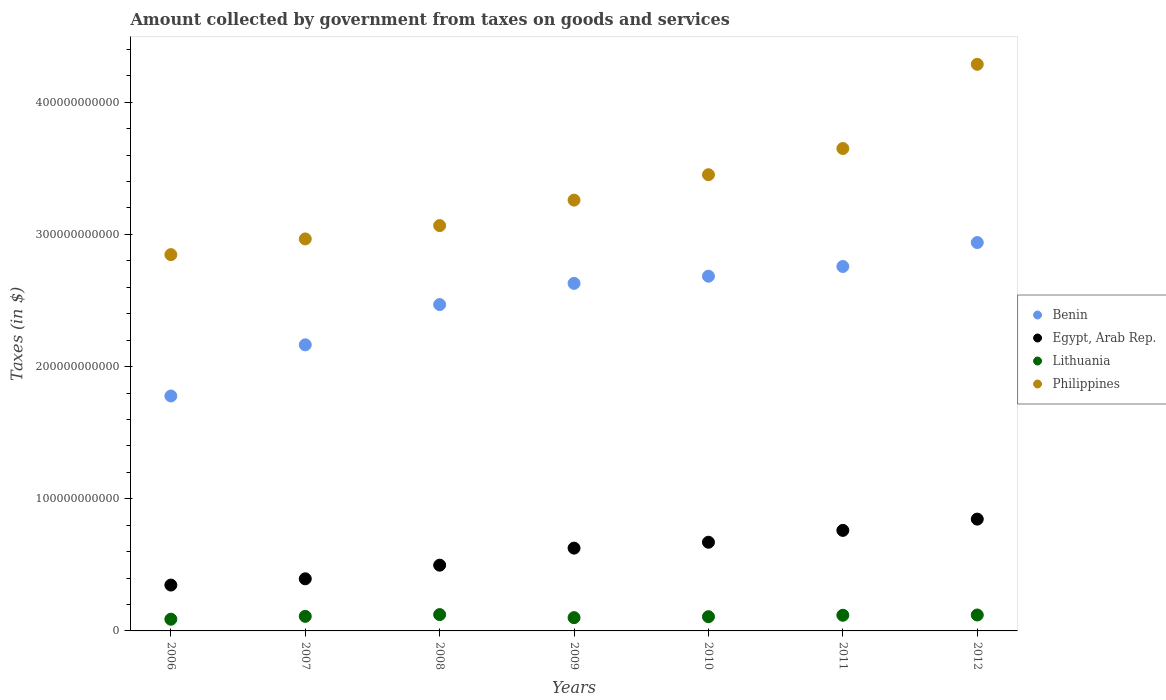Is the number of dotlines equal to the number of legend labels?
Your answer should be very brief. Yes. What is the amount collected by government from taxes on goods and services in Egypt, Arab Rep. in 2007?
Provide a short and direct response. 3.94e+1. Across all years, what is the maximum amount collected by government from taxes on goods and services in Lithuania?
Keep it short and to the point. 1.24e+1. Across all years, what is the minimum amount collected by government from taxes on goods and services in Benin?
Your answer should be compact. 1.78e+11. In which year was the amount collected by government from taxes on goods and services in Benin maximum?
Provide a succinct answer. 2012. In which year was the amount collected by government from taxes on goods and services in Philippines minimum?
Give a very brief answer. 2006. What is the total amount collected by government from taxes on goods and services in Lithuania in the graph?
Ensure brevity in your answer.  7.70e+1. What is the difference between the amount collected by government from taxes on goods and services in Benin in 2009 and that in 2011?
Provide a succinct answer. -1.28e+1. What is the difference between the amount collected by government from taxes on goods and services in Philippines in 2009 and the amount collected by government from taxes on goods and services in Egypt, Arab Rep. in 2008?
Give a very brief answer. 2.76e+11. What is the average amount collected by government from taxes on goods and services in Benin per year?
Keep it short and to the point. 2.49e+11. In the year 2012, what is the difference between the amount collected by government from taxes on goods and services in Egypt, Arab Rep. and amount collected by government from taxes on goods and services in Philippines?
Your answer should be very brief. -3.44e+11. In how many years, is the amount collected by government from taxes on goods and services in Egypt, Arab Rep. greater than 160000000000 $?
Offer a terse response. 0. What is the ratio of the amount collected by government from taxes on goods and services in Philippines in 2007 to that in 2008?
Your answer should be very brief. 0.97. Is the difference between the amount collected by government from taxes on goods and services in Egypt, Arab Rep. in 2007 and 2011 greater than the difference between the amount collected by government from taxes on goods and services in Philippines in 2007 and 2011?
Make the answer very short. Yes. What is the difference between the highest and the second highest amount collected by government from taxes on goods and services in Egypt, Arab Rep.?
Offer a terse response. 8.53e+09. What is the difference between the highest and the lowest amount collected by government from taxes on goods and services in Lithuania?
Ensure brevity in your answer.  3.50e+09. In how many years, is the amount collected by government from taxes on goods and services in Benin greater than the average amount collected by government from taxes on goods and services in Benin taken over all years?
Offer a very short reply. 4. Is the sum of the amount collected by government from taxes on goods and services in Lithuania in 2007 and 2008 greater than the maximum amount collected by government from taxes on goods and services in Benin across all years?
Ensure brevity in your answer.  No. Is it the case that in every year, the sum of the amount collected by government from taxes on goods and services in Egypt, Arab Rep. and amount collected by government from taxes on goods and services in Lithuania  is greater than the amount collected by government from taxes on goods and services in Benin?
Your answer should be compact. No. Does the amount collected by government from taxes on goods and services in Benin monotonically increase over the years?
Make the answer very short. Yes. Is the amount collected by government from taxes on goods and services in Lithuania strictly less than the amount collected by government from taxes on goods and services in Philippines over the years?
Offer a terse response. Yes. How many dotlines are there?
Your response must be concise. 4. How many years are there in the graph?
Make the answer very short. 7. What is the difference between two consecutive major ticks on the Y-axis?
Your answer should be very brief. 1.00e+11. Are the values on the major ticks of Y-axis written in scientific E-notation?
Your answer should be very brief. No. Does the graph contain any zero values?
Provide a succinct answer. No. How many legend labels are there?
Give a very brief answer. 4. How are the legend labels stacked?
Your answer should be compact. Vertical. What is the title of the graph?
Offer a very short reply. Amount collected by government from taxes on goods and services. Does "Azerbaijan" appear as one of the legend labels in the graph?
Offer a terse response. No. What is the label or title of the Y-axis?
Your answer should be compact. Taxes (in $). What is the Taxes (in $) of Benin in 2006?
Your answer should be very brief. 1.78e+11. What is the Taxes (in $) of Egypt, Arab Rep. in 2006?
Offer a terse response. 3.47e+1. What is the Taxes (in $) in Lithuania in 2006?
Your response must be concise. 8.86e+09. What is the Taxes (in $) in Philippines in 2006?
Your answer should be very brief. 2.85e+11. What is the Taxes (in $) in Benin in 2007?
Ensure brevity in your answer.  2.16e+11. What is the Taxes (in $) in Egypt, Arab Rep. in 2007?
Ensure brevity in your answer.  3.94e+1. What is the Taxes (in $) of Lithuania in 2007?
Give a very brief answer. 1.10e+1. What is the Taxes (in $) in Philippines in 2007?
Make the answer very short. 2.97e+11. What is the Taxes (in $) in Benin in 2008?
Give a very brief answer. 2.47e+11. What is the Taxes (in $) of Egypt, Arab Rep. in 2008?
Keep it short and to the point. 4.97e+1. What is the Taxes (in $) of Lithuania in 2008?
Provide a short and direct response. 1.24e+1. What is the Taxes (in $) of Philippines in 2008?
Your answer should be very brief. 3.07e+11. What is the Taxes (in $) in Benin in 2009?
Your answer should be very brief. 2.63e+11. What is the Taxes (in $) of Egypt, Arab Rep. in 2009?
Provide a succinct answer. 6.26e+1. What is the Taxes (in $) of Lithuania in 2009?
Offer a very short reply. 1.00e+1. What is the Taxes (in $) in Philippines in 2009?
Keep it short and to the point. 3.26e+11. What is the Taxes (in $) of Benin in 2010?
Offer a terse response. 2.68e+11. What is the Taxes (in $) of Egypt, Arab Rep. in 2010?
Provide a short and direct response. 6.71e+1. What is the Taxes (in $) in Lithuania in 2010?
Give a very brief answer. 1.08e+1. What is the Taxes (in $) in Philippines in 2010?
Your response must be concise. 3.45e+11. What is the Taxes (in $) of Benin in 2011?
Make the answer very short. 2.76e+11. What is the Taxes (in $) of Egypt, Arab Rep. in 2011?
Ensure brevity in your answer.  7.61e+1. What is the Taxes (in $) of Lithuania in 2011?
Provide a short and direct response. 1.19e+1. What is the Taxes (in $) of Philippines in 2011?
Offer a terse response. 3.65e+11. What is the Taxes (in $) of Benin in 2012?
Offer a very short reply. 2.94e+11. What is the Taxes (in $) in Egypt, Arab Rep. in 2012?
Your answer should be very brief. 8.46e+1. What is the Taxes (in $) of Lithuania in 2012?
Your answer should be very brief. 1.21e+1. What is the Taxes (in $) of Philippines in 2012?
Offer a very short reply. 4.29e+11. Across all years, what is the maximum Taxes (in $) in Benin?
Provide a short and direct response. 2.94e+11. Across all years, what is the maximum Taxes (in $) of Egypt, Arab Rep.?
Provide a short and direct response. 8.46e+1. Across all years, what is the maximum Taxes (in $) of Lithuania?
Keep it short and to the point. 1.24e+1. Across all years, what is the maximum Taxes (in $) in Philippines?
Ensure brevity in your answer.  4.29e+11. Across all years, what is the minimum Taxes (in $) in Benin?
Give a very brief answer. 1.78e+11. Across all years, what is the minimum Taxes (in $) in Egypt, Arab Rep.?
Your answer should be very brief. 3.47e+1. Across all years, what is the minimum Taxes (in $) of Lithuania?
Offer a terse response. 8.86e+09. Across all years, what is the minimum Taxes (in $) in Philippines?
Your answer should be compact. 2.85e+11. What is the total Taxes (in $) in Benin in the graph?
Your answer should be compact. 1.74e+12. What is the total Taxes (in $) of Egypt, Arab Rep. in the graph?
Offer a very short reply. 4.14e+11. What is the total Taxes (in $) in Lithuania in the graph?
Your answer should be compact. 7.70e+1. What is the total Taxes (in $) in Philippines in the graph?
Ensure brevity in your answer.  2.35e+12. What is the difference between the Taxes (in $) in Benin in 2006 and that in 2007?
Provide a succinct answer. -3.87e+1. What is the difference between the Taxes (in $) of Egypt, Arab Rep. in 2006 and that in 2007?
Provide a succinct answer. -4.74e+09. What is the difference between the Taxes (in $) of Lithuania in 2006 and that in 2007?
Offer a terse response. -2.17e+09. What is the difference between the Taxes (in $) in Philippines in 2006 and that in 2007?
Provide a succinct answer. -1.19e+1. What is the difference between the Taxes (in $) in Benin in 2006 and that in 2008?
Offer a very short reply. -6.92e+1. What is the difference between the Taxes (in $) in Egypt, Arab Rep. in 2006 and that in 2008?
Your answer should be compact. -1.50e+1. What is the difference between the Taxes (in $) of Lithuania in 2006 and that in 2008?
Make the answer very short. -3.50e+09. What is the difference between the Taxes (in $) in Philippines in 2006 and that in 2008?
Give a very brief answer. -2.20e+1. What is the difference between the Taxes (in $) of Benin in 2006 and that in 2009?
Offer a terse response. -8.52e+1. What is the difference between the Taxes (in $) of Egypt, Arab Rep. in 2006 and that in 2009?
Your response must be concise. -2.80e+1. What is the difference between the Taxes (in $) in Lithuania in 2006 and that in 2009?
Your answer should be compact. -1.18e+09. What is the difference between the Taxes (in $) in Philippines in 2006 and that in 2009?
Give a very brief answer. -4.12e+1. What is the difference between the Taxes (in $) of Benin in 2006 and that in 2010?
Your answer should be very brief. -9.06e+1. What is the difference between the Taxes (in $) in Egypt, Arab Rep. in 2006 and that in 2010?
Your answer should be compact. -3.24e+1. What is the difference between the Taxes (in $) in Lithuania in 2006 and that in 2010?
Provide a succinct answer. -1.90e+09. What is the difference between the Taxes (in $) of Philippines in 2006 and that in 2010?
Give a very brief answer. -6.05e+1. What is the difference between the Taxes (in $) in Benin in 2006 and that in 2011?
Your response must be concise. -9.80e+1. What is the difference between the Taxes (in $) of Egypt, Arab Rep. in 2006 and that in 2011?
Offer a very short reply. -4.14e+1. What is the difference between the Taxes (in $) in Lithuania in 2006 and that in 2011?
Offer a terse response. -3.00e+09. What is the difference between the Taxes (in $) in Philippines in 2006 and that in 2011?
Ensure brevity in your answer.  -8.03e+1. What is the difference between the Taxes (in $) in Benin in 2006 and that in 2012?
Your response must be concise. -1.16e+11. What is the difference between the Taxes (in $) of Egypt, Arab Rep. in 2006 and that in 2012?
Provide a short and direct response. -4.99e+1. What is the difference between the Taxes (in $) of Lithuania in 2006 and that in 2012?
Keep it short and to the point. -3.20e+09. What is the difference between the Taxes (in $) in Philippines in 2006 and that in 2012?
Your response must be concise. -1.44e+11. What is the difference between the Taxes (in $) of Benin in 2007 and that in 2008?
Make the answer very short. -3.05e+1. What is the difference between the Taxes (in $) of Egypt, Arab Rep. in 2007 and that in 2008?
Your answer should be very brief. -1.03e+1. What is the difference between the Taxes (in $) in Lithuania in 2007 and that in 2008?
Provide a short and direct response. -1.33e+09. What is the difference between the Taxes (in $) of Philippines in 2007 and that in 2008?
Make the answer very short. -1.01e+1. What is the difference between the Taxes (in $) of Benin in 2007 and that in 2009?
Provide a succinct answer. -4.65e+1. What is the difference between the Taxes (in $) of Egypt, Arab Rep. in 2007 and that in 2009?
Your answer should be very brief. -2.32e+1. What is the difference between the Taxes (in $) in Lithuania in 2007 and that in 2009?
Provide a short and direct response. 9.84e+08. What is the difference between the Taxes (in $) of Philippines in 2007 and that in 2009?
Your response must be concise. -2.94e+1. What is the difference between the Taxes (in $) of Benin in 2007 and that in 2010?
Offer a terse response. -5.19e+1. What is the difference between the Taxes (in $) in Egypt, Arab Rep. in 2007 and that in 2010?
Your response must be concise. -2.77e+1. What is the difference between the Taxes (in $) in Lithuania in 2007 and that in 2010?
Your answer should be very brief. 2.73e+08. What is the difference between the Taxes (in $) of Philippines in 2007 and that in 2010?
Give a very brief answer. -4.86e+1. What is the difference between the Taxes (in $) in Benin in 2007 and that in 2011?
Keep it short and to the point. -5.93e+1. What is the difference between the Taxes (in $) of Egypt, Arab Rep. in 2007 and that in 2011?
Your response must be concise. -3.66e+1. What is the difference between the Taxes (in $) in Lithuania in 2007 and that in 2011?
Your answer should be very brief. -8.32e+08. What is the difference between the Taxes (in $) of Philippines in 2007 and that in 2011?
Provide a succinct answer. -6.84e+1. What is the difference between the Taxes (in $) in Benin in 2007 and that in 2012?
Offer a terse response. -7.74e+1. What is the difference between the Taxes (in $) of Egypt, Arab Rep. in 2007 and that in 2012?
Keep it short and to the point. -4.52e+1. What is the difference between the Taxes (in $) of Lithuania in 2007 and that in 2012?
Offer a terse response. -1.03e+09. What is the difference between the Taxes (in $) in Philippines in 2007 and that in 2012?
Keep it short and to the point. -1.32e+11. What is the difference between the Taxes (in $) of Benin in 2008 and that in 2009?
Offer a terse response. -1.60e+1. What is the difference between the Taxes (in $) of Egypt, Arab Rep. in 2008 and that in 2009?
Ensure brevity in your answer.  -1.29e+1. What is the difference between the Taxes (in $) of Lithuania in 2008 and that in 2009?
Your answer should be very brief. 2.31e+09. What is the difference between the Taxes (in $) in Philippines in 2008 and that in 2009?
Your answer should be very brief. -1.93e+1. What is the difference between the Taxes (in $) of Benin in 2008 and that in 2010?
Keep it short and to the point. -2.15e+1. What is the difference between the Taxes (in $) of Egypt, Arab Rep. in 2008 and that in 2010?
Keep it short and to the point. -1.73e+1. What is the difference between the Taxes (in $) in Lithuania in 2008 and that in 2010?
Keep it short and to the point. 1.60e+09. What is the difference between the Taxes (in $) in Philippines in 2008 and that in 2010?
Provide a short and direct response. -3.85e+1. What is the difference between the Taxes (in $) in Benin in 2008 and that in 2011?
Make the answer very short. -2.88e+1. What is the difference between the Taxes (in $) in Egypt, Arab Rep. in 2008 and that in 2011?
Provide a succinct answer. -2.63e+1. What is the difference between the Taxes (in $) of Lithuania in 2008 and that in 2011?
Provide a short and direct response. 4.96e+08. What is the difference between the Taxes (in $) of Philippines in 2008 and that in 2011?
Offer a very short reply. -5.83e+1. What is the difference between the Taxes (in $) of Benin in 2008 and that in 2012?
Make the answer very short. -4.69e+1. What is the difference between the Taxes (in $) of Egypt, Arab Rep. in 2008 and that in 2012?
Your answer should be compact. -3.48e+1. What is the difference between the Taxes (in $) in Lithuania in 2008 and that in 2012?
Make the answer very short. 2.98e+08. What is the difference between the Taxes (in $) of Philippines in 2008 and that in 2012?
Provide a short and direct response. -1.22e+11. What is the difference between the Taxes (in $) in Benin in 2009 and that in 2010?
Your answer should be compact. -5.42e+09. What is the difference between the Taxes (in $) of Egypt, Arab Rep. in 2009 and that in 2010?
Your response must be concise. -4.44e+09. What is the difference between the Taxes (in $) of Lithuania in 2009 and that in 2010?
Provide a short and direct response. -7.11e+08. What is the difference between the Taxes (in $) of Philippines in 2009 and that in 2010?
Offer a very short reply. -1.92e+1. What is the difference between the Taxes (in $) of Benin in 2009 and that in 2011?
Offer a very short reply. -1.28e+1. What is the difference between the Taxes (in $) in Egypt, Arab Rep. in 2009 and that in 2011?
Make the answer very short. -1.34e+1. What is the difference between the Taxes (in $) in Lithuania in 2009 and that in 2011?
Make the answer very short. -1.82e+09. What is the difference between the Taxes (in $) in Philippines in 2009 and that in 2011?
Make the answer very short. -3.91e+1. What is the difference between the Taxes (in $) of Benin in 2009 and that in 2012?
Provide a short and direct response. -3.09e+1. What is the difference between the Taxes (in $) in Egypt, Arab Rep. in 2009 and that in 2012?
Offer a very short reply. -2.19e+1. What is the difference between the Taxes (in $) in Lithuania in 2009 and that in 2012?
Give a very brief answer. -2.01e+09. What is the difference between the Taxes (in $) of Philippines in 2009 and that in 2012?
Provide a short and direct response. -1.03e+11. What is the difference between the Taxes (in $) of Benin in 2010 and that in 2011?
Your response must be concise. -7.35e+09. What is the difference between the Taxes (in $) of Egypt, Arab Rep. in 2010 and that in 2011?
Your answer should be very brief. -8.97e+09. What is the difference between the Taxes (in $) in Lithuania in 2010 and that in 2011?
Keep it short and to the point. -1.11e+09. What is the difference between the Taxes (in $) of Philippines in 2010 and that in 2011?
Ensure brevity in your answer.  -1.98e+1. What is the difference between the Taxes (in $) of Benin in 2010 and that in 2012?
Your answer should be compact. -2.55e+1. What is the difference between the Taxes (in $) of Egypt, Arab Rep. in 2010 and that in 2012?
Make the answer very short. -1.75e+1. What is the difference between the Taxes (in $) of Lithuania in 2010 and that in 2012?
Your response must be concise. -1.30e+09. What is the difference between the Taxes (in $) of Philippines in 2010 and that in 2012?
Ensure brevity in your answer.  -8.35e+1. What is the difference between the Taxes (in $) of Benin in 2011 and that in 2012?
Your response must be concise. -1.81e+1. What is the difference between the Taxes (in $) of Egypt, Arab Rep. in 2011 and that in 2012?
Give a very brief answer. -8.53e+09. What is the difference between the Taxes (in $) in Lithuania in 2011 and that in 2012?
Keep it short and to the point. -1.98e+08. What is the difference between the Taxes (in $) in Philippines in 2011 and that in 2012?
Make the answer very short. -6.37e+1. What is the difference between the Taxes (in $) in Benin in 2006 and the Taxes (in $) in Egypt, Arab Rep. in 2007?
Offer a very short reply. 1.38e+11. What is the difference between the Taxes (in $) of Benin in 2006 and the Taxes (in $) of Lithuania in 2007?
Your answer should be very brief. 1.67e+11. What is the difference between the Taxes (in $) of Benin in 2006 and the Taxes (in $) of Philippines in 2007?
Provide a succinct answer. -1.19e+11. What is the difference between the Taxes (in $) in Egypt, Arab Rep. in 2006 and the Taxes (in $) in Lithuania in 2007?
Make the answer very short. 2.37e+1. What is the difference between the Taxes (in $) of Egypt, Arab Rep. in 2006 and the Taxes (in $) of Philippines in 2007?
Offer a terse response. -2.62e+11. What is the difference between the Taxes (in $) in Lithuania in 2006 and the Taxes (in $) in Philippines in 2007?
Provide a succinct answer. -2.88e+11. What is the difference between the Taxes (in $) in Benin in 2006 and the Taxes (in $) in Egypt, Arab Rep. in 2008?
Your answer should be very brief. 1.28e+11. What is the difference between the Taxes (in $) of Benin in 2006 and the Taxes (in $) of Lithuania in 2008?
Keep it short and to the point. 1.65e+11. What is the difference between the Taxes (in $) of Benin in 2006 and the Taxes (in $) of Philippines in 2008?
Give a very brief answer. -1.29e+11. What is the difference between the Taxes (in $) of Egypt, Arab Rep. in 2006 and the Taxes (in $) of Lithuania in 2008?
Offer a very short reply. 2.23e+1. What is the difference between the Taxes (in $) of Egypt, Arab Rep. in 2006 and the Taxes (in $) of Philippines in 2008?
Provide a short and direct response. -2.72e+11. What is the difference between the Taxes (in $) in Lithuania in 2006 and the Taxes (in $) in Philippines in 2008?
Your response must be concise. -2.98e+11. What is the difference between the Taxes (in $) of Benin in 2006 and the Taxes (in $) of Egypt, Arab Rep. in 2009?
Your answer should be compact. 1.15e+11. What is the difference between the Taxes (in $) of Benin in 2006 and the Taxes (in $) of Lithuania in 2009?
Provide a succinct answer. 1.68e+11. What is the difference between the Taxes (in $) in Benin in 2006 and the Taxes (in $) in Philippines in 2009?
Your answer should be compact. -1.48e+11. What is the difference between the Taxes (in $) in Egypt, Arab Rep. in 2006 and the Taxes (in $) in Lithuania in 2009?
Your answer should be compact. 2.47e+1. What is the difference between the Taxes (in $) of Egypt, Arab Rep. in 2006 and the Taxes (in $) of Philippines in 2009?
Your answer should be very brief. -2.91e+11. What is the difference between the Taxes (in $) in Lithuania in 2006 and the Taxes (in $) in Philippines in 2009?
Ensure brevity in your answer.  -3.17e+11. What is the difference between the Taxes (in $) of Benin in 2006 and the Taxes (in $) of Egypt, Arab Rep. in 2010?
Give a very brief answer. 1.11e+11. What is the difference between the Taxes (in $) of Benin in 2006 and the Taxes (in $) of Lithuania in 2010?
Give a very brief answer. 1.67e+11. What is the difference between the Taxes (in $) of Benin in 2006 and the Taxes (in $) of Philippines in 2010?
Keep it short and to the point. -1.67e+11. What is the difference between the Taxes (in $) in Egypt, Arab Rep. in 2006 and the Taxes (in $) in Lithuania in 2010?
Your response must be concise. 2.39e+1. What is the difference between the Taxes (in $) of Egypt, Arab Rep. in 2006 and the Taxes (in $) of Philippines in 2010?
Your answer should be compact. -3.10e+11. What is the difference between the Taxes (in $) of Lithuania in 2006 and the Taxes (in $) of Philippines in 2010?
Make the answer very short. -3.36e+11. What is the difference between the Taxes (in $) in Benin in 2006 and the Taxes (in $) in Egypt, Arab Rep. in 2011?
Keep it short and to the point. 1.02e+11. What is the difference between the Taxes (in $) in Benin in 2006 and the Taxes (in $) in Lithuania in 2011?
Offer a very short reply. 1.66e+11. What is the difference between the Taxes (in $) of Benin in 2006 and the Taxes (in $) of Philippines in 2011?
Offer a very short reply. -1.87e+11. What is the difference between the Taxes (in $) of Egypt, Arab Rep. in 2006 and the Taxes (in $) of Lithuania in 2011?
Offer a very short reply. 2.28e+1. What is the difference between the Taxes (in $) in Egypt, Arab Rep. in 2006 and the Taxes (in $) in Philippines in 2011?
Keep it short and to the point. -3.30e+11. What is the difference between the Taxes (in $) in Lithuania in 2006 and the Taxes (in $) in Philippines in 2011?
Ensure brevity in your answer.  -3.56e+11. What is the difference between the Taxes (in $) of Benin in 2006 and the Taxes (in $) of Egypt, Arab Rep. in 2012?
Your answer should be compact. 9.32e+1. What is the difference between the Taxes (in $) in Benin in 2006 and the Taxes (in $) in Lithuania in 2012?
Your answer should be very brief. 1.66e+11. What is the difference between the Taxes (in $) in Benin in 2006 and the Taxes (in $) in Philippines in 2012?
Ensure brevity in your answer.  -2.51e+11. What is the difference between the Taxes (in $) of Egypt, Arab Rep. in 2006 and the Taxes (in $) of Lithuania in 2012?
Give a very brief answer. 2.26e+1. What is the difference between the Taxes (in $) in Egypt, Arab Rep. in 2006 and the Taxes (in $) in Philippines in 2012?
Provide a short and direct response. -3.94e+11. What is the difference between the Taxes (in $) in Lithuania in 2006 and the Taxes (in $) in Philippines in 2012?
Offer a very short reply. -4.20e+11. What is the difference between the Taxes (in $) of Benin in 2007 and the Taxes (in $) of Egypt, Arab Rep. in 2008?
Your answer should be very brief. 1.67e+11. What is the difference between the Taxes (in $) of Benin in 2007 and the Taxes (in $) of Lithuania in 2008?
Offer a terse response. 2.04e+11. What is the difference between the Taxes (in $) in Benin in 2007 and the Taxes (in $) in Philippines in 2008?
Your answer should be very brief. -9.02e+1. What is the difference between the Taxes (in $) of Egypt, Arab Rep. in 2007 and the Taxes (in $) of Lithuania in 2008?
Provide a succinct answer. 2.71e+1. What is the difference between the Taxes (in $) of Egypt, Arab Rep. in 2007 and the Taxes (in $) of Philippines in 2008?
Give a very brief answer. -2.67e+11. What is the difference between the Taxes (in $) in Lithuania in 2007 and the Taxes (in $) in Philippines in 2008?
Offer a terse response. -2.96e+11. What is the difference between the Taxes (in $) of Benin in 2007 and the Taxes (in $) of Egypt, Arab Rep. in 2009?
Provide a short and direct response. 1.54e+11. What is the difference between the Taxes (in $) in Benin in 2007 and the Taxes (in $) in Lithuania in 2009?
Provide a succinct answer. 2.06e+11. What is the difference between the Taxes (in $) in Benin in 2007 and the Taxes (in $) in Philippines in 2009?
Ensure brevity in your answer.  -1.09e+11. What is the difference between the Taxes (in $) in Egypt, Arab Rep. in 2007 and the Taxes (in $) in Lithuania in 2009?
Make the answer very short. 2.94e+1. What is the difference between the Taxes (in $) of Egypt, Arab Rep. in 2007 and the Taxes (in $) of Philippines in 2009?
Ensure brevity in your answer.  -2.87e+11. What is the difference between the Taxes (in $) of Lithuania in 2007 and the Taxes (in $) of Philippines in 2009?
Make the answer very short. -3.15e+11. What is the difference between the Taxes (in $) of Benin in 2007 and the Taxes (in $) of Egypt, Arab Rep. in 2010?
Ensure brevity in your answer.  1.49e+11. What is the difference between the Taxes (in $) in Benin in 2007 and the Taxes (in $) in Lithuania in 2010?
Provide a succinct answer. 2.06e+11. What is the difference between the Taxes (in $) in Benin in 2007 and the Taxes (in $) in Philippines in 2010?
Give a very brief answer. -1.29e+11. What is the difference between the Taxes (in $) in Egypt, Arab Rep. in 2007 and the Taxes (in $) in Lithuania in 2010?
Your answer should be very brief. 2.87e+1. What is the difference between the Taxes (in $) in Egypt, Arab Rep. in 2007 and the Taxes (in $) in Philippines in 2010?
Provide a succinct answer. -3.06e+11. What is the difference between the Taxes (in $) in Lithuania in 2007 and the Taxes (in $) in Philippines in 2010?
Provide a short and direct response. -3.34e+11. What is the difference between the Taxes (in $) in Benin in 2007 and the Taxes (in $) in Egypt, Arab Rep. in 2011?
Offer a terse response. 1.40e+11. What is the difference between the Taxes (in $) of Benin in 2007 and the Taxes (in $) of Lithuania in 2011?
Provide a short and direct response. 2.05e+11. What is the difference between the Taxes (in $) in Benin in 2007 and the Taxes (in $) in Philippines in 2011?
Give a very brief answer. -1.49e+11. What is the difference between the Taxes (in $) of Egypt, Arab Rep. in 2007 and the Taxes (in $) of Lithuania in 2011?
Your answer should be compact. 2.76e+1. What is the difference between the Taxes (in $) of Egypt, Arab Rep. in 2007 and the Taxes (in $) of Philippines in 2011?
Give a very brief answer. -3.26e+11. What is the difference between the Taxes (in $) in Lithuania in 2007 and the Taxes (in $) in Philippines in 2011?
Give a very brief answer. -3.54e+11. What is the difference between the Taxes (in $) in Benin in 2007 and the Taxes (in $) in Egypt, Arab Rep. in 2012?
Offer a very short reply. 1.32e+11. What is the difference between the Taxes (in $) in Benin in 2007 and the Taxes (in $) in Lithuania in 2012?
Your answer should be very brief. 2.04e+11. What is the difference between the Taxes (in $) of Benin in 2007 and the Taxes (in $) of Philippines in 2012?
Make the answer very short. -2.12e+11. What is the difference between the Taxes (in $) in Egypt, Arab Rep. in 2007 and the Taxes (in $) in Lithuania in 2012?
Ensure brevity in your answer.  2.74e+1. What is the difference between the Taxes (in $) in Egypt, Arab Rep. in 2007 and the Taxes (in $) in Philippines in 2012?
Offer a terse response. -3.89e+11. What is the difference between the Taxes (in $) in Lithuania in 2007 and the Taxes (in $) in Philippines in 2012?
Keep it short and to the point. -4.18e+11. What is the difference between the Taxes (in $) of Benin in 2008 and the Taxes (in $) of Egypt, Arab Rep. in 2009?
Provide a short and direct response. 1.84e+11. What is the difference between the Taxes (in $) of Benin in 2008 and the Taxes (in $) of Lithuania in 2009?
Your answer should be compact. 2.37e+11. What is the difference between the Taxes (in $) of Benin in 2008 and the Taxes (in $) of Philippines in 2009?
Your answer should be very brief. -7.90e+1. What is the difference between the Taxes (in $) in Egypt, Arab Rep. in 2008 and the Taxes (in $) in Lithuania in 2009?
Offer a very short reply. 3.97e+1. What is the difference between the Taxes (in $) in Egypt, Arab Rep. in 2008 and the Taxes (in $) in Philippines in 2009?
Your response must be concise. -2.76e+11. What is the difference between the Taxes (in $) in Lithuania in 2008 and the Taxes (in $) in Philippines in 2009?
Your answer should be compact. -3.14e+11. What is the difference between the Taxes (in $) in Benin in 2008 and the Taxes (in $) in Egypt, Arab Rep. in 2010?
Your answer should be very brief. 1.80e+11. What is the difference between the Taxes (in $) of Benin in 2008 and the Taxes (in $) of Lithuania in 2010?
Make the answer very short. 2.36e+11. What is the difference between the Taxes (in $) in Benin in 2008 and the Taxes (in $) in Philippines in 2010?
Give a very brief answer. -9.83e+1. What is the difference between the Taxes (in $) in Egypt, Arab Rep. in 2008 and the Taxes (in $) in Lithuania in 2010?
Offer a terse response. 3.90e+1. What is the difference between the Taxes (in $) in Egypt, Arab Rep. in 2008 and the Taxes (in $) in Philippines in 2010?
Provide a short and direct response. -2.95e+11. What is the difference between the Taxes (in $) in Lithuania in 2008 and the Taxes (in $) in Philippines in 2010?
Ensure brevity in your answer.  -3.33e+11. What is the difference between the Taxes (in $) of Benin in 2008 and the Taxes (in $) of Egypt, Arab Rep. in 2011?
Give a very brief answer. 1.71e+11. What is the difference between the Taxes (in $) in Benin in 2008 and the Taxes (in $) in Lithuania in 2011?
Ensure brevity in your answer.  2.35e+11. What is the difference between the Taxes (in $) of Benin in 2008 and the Taxes (in $) of Philippines in 2011?
Offer a terse response. -1.18e+11. What is the difference between the Taxes (in $) of Egypt, Arab Rep. in 2008 and the Taxes (in $) of Lithuania in 2011?
Your answer should be compact. 3.79e+1. What is the difference between the Taxes (in $) in Egypt, Arab Rep. in 2008 and the Taxes (in $) in Philippines in 2011?
Your response must be concise. -3.15e+11. What is the difference between the Taxes (in $) of Lithuania in 2008 and the Taxes (in $) of Philippines in 2011?
Offer a very short reply. -3.53e+11. What is the difference between the Taxes (in $) of Benin in 2008 and the Taxes (in $) of Egypt, Arab Rep. in 2012?
Give a very brief answer. 1.62e+11. What is the difference between the Taxes (in $) of Benin in 2008 and the Taxes (in $) of Lithuania in 2012?
Give a very brief answer. 2.35e+11. What is the difference between the Taxes (in $) of Benin in 2008 and the Taxes (in $) of Philippines in 2012?
Keep it short and to the point. -1.82e+11. What is the difference between the Taxes (in $) of Egypt, Arab Rep. in 2008 and the Taxes (in $) of Lithuania in 2012?
Make the answer very short. 3.77e+1. What is the difference between the Taxes (in $) in Egypt, Arab Rep. in 2008 and the Taxes (in $) in Philippines in 2012?
Provide a short and direct response. -3.79e+11. What is the difference between the Taxes (in $) in Lithuania in 2008 and the Taxes (in $) in Philippines in 2012?
Offer a very short reply. -4.16e+11. What is the difference between the Taxes (in $) in Benin in 2009 and the Taxes (in $) in Egypt, Arab Rep. in 2010?
Make the answer very short. 1.96e+11. What is the difference between the Taxes (in $) of Benin in 2009 and the Taxes (in $) of Lithuania in 2010?
Offer a terse response. 2.52e+11. What is the difference between the Taxes (in $) in Benin in 2009 and the Taxes (in $) in Philippines in 2010?
Offer a very short reply. -8.22e+1. What is the difference between the Taxes (in $) in Egypt, Arab Rep. in 2009 and the Taxes (in $) in Lithuania in 2010?
Provide a succinct answer. 5.19e+1. What is the difference between the Taxes (in $) in Egypt, Arab Rep. in 2009 and the Taxes (in $) in Philippines in 2010?
Offer a very short reply. -2.83e+11. What is the difference between the Taxes (in $) of Lithuania in 2009 and the Taxes (in $) of Philippines in 2010?
Give a very brief answer. -3.35e+11. What is the difference between the Taxes (in $) of Benin in 2009 and the Taxes (in $) of Egypt, Arab Rep. in 2011?
Make the answer very short. 1.87e+11. What is the difference between the Taxes (in $) of Benin in 2009 and the Taxes (in $) of Lithuania in 2011?
Your answer should be very brief. 2.51e+11. What is the difference between the Taxes (in $) in Benin in 2009 and the Taxes (in $) in Philippines in 2011?
Provide a succinct answer. -1.02e+11. What is the difference between the Taxes (in $) of Egypt, Arab Rep. in 2009 and the Taxes (in $) of Lithuania in 2011?
Provide a short and direct response. 5.08e+1. What is the difference between the Taxes (in $) in Egypt, Arab Rep. in 2009 and the Taxes (in $) in Philippines in 2011?
Make the answer very short. -3.02e+11. What is the difference between the Taxes (in $) in Lithuania in 2009 and the Taxes (in $) in Philippines in 2011?
Keep it short and to the point. -3.55e+11. What is the difference between the Taxes (in $) in Benin in 2009 and the Taxes (in $) in Egypt, Arab Rep. in 2012?
Provide a succinct answer. 1.78e+11. What is the difference between the Taxes (in $) of Benin in 2009 and the Taxes (in $) of Lithuania in 2012?
Your answer should be compact. 2.51e+11. What is the difference between the Taxes (in $) in Benin in 2009 and the Taxes (in $) in Philippines in 2012?
Make the answer very short. -1.66e+11. What is the difference between the Taxes (in $) of Egypt, Arab Rep. in 2009 and the Taxes (in $) of Lithuania in 2012?
Your answer should be very brief. 5.06e+1. What is the difference between the Taxes (in $) of Egypt, Arab Rep. in 2009 and the Taxes (in $) of Philippines in 2012?
Provide a succinct answer. -3.66e+11. What is the difference between the Taxes (in $) of Lithuania in 2009 and the Taxes (in $) of Philippines in 2012?
Your answer should be compact. -4.19e+11. What is the difference between the Taxes (in $) of Benin in 2010 and the Taxes (in $) of Egypt, Arab Rep. in 2011?
Offer a terse response. 1.92e+11. What is the difference between the Taxes (in $) of Benin in 2010 and the Taxes (in $) of Lithuania in 2011?
Ensure brevity in your answer.  2.57e+11. What is the difference between the Taxes (in $) in Benin in 2010 and the Taxes (in $) in Philippines in 2011?
Provide a succinct answer. -9.66e+1. What is the difference between the Taxes (in $) of Egypt, Arab Rep. in 2010 and the Taxes (in $) of Lithuania in 2011?
Ensure brevity in your answer.  5.52e+1. What is the difference between the Taxes (in $) of Egypt, Arab Rep. in 2010 and the Taxes (in $) of Philippines in 2011?
Ensure brevity in your answer.  -2.98e+11. What is the difference between the Taxes (in $) in Lithuania in 2010 and the Taxes (in $) in Philippines in 2011?
Give a very brief answer. -3.54e+11. What is the difference between the Taxes (in $) of Benin in 2010 and the Taxes (in $) of Egypt, Arab Rep. in 2012?
Your answer should be very brief. 1.84e+11. What is the difference between the Taxes (in $) in Benin in 2010 and the Taxes (in $) in Lithuania in 2012?
Your answer should be very brief. 2.56e+11. What is the difference between the Taxes (in $) in Benin in 2010 and the Taxes (in $) in Philippines in 2012?
Your response must be concise. -1.60e+11. What is the difference between the Taxes (in $) of Egypt, Arab Rep. in 2010 and the Taxes (in $) of Lithuania in 2012?
Provide a succinct answer. 5.50e+1. What is the difference between the Taxes (in $) of Egypt, Arab Rep. in 2010 and the Taxes (in $) of Philippines in 2012?
Give a very brief answer. -3.62e+11. What is the difference between the Taxes (in $) of Lithuania in 2010 and the Taxes (in $) of Philippines in 2012?
Provide a short and direct response. -4.18e+11. What is the difference between the Taxes (in $) in Benin in 2011 and the Taxes (in $) in Egypt, Arab Rep. in 2012?
Ensure brevity in your answer.  1.91e+11. What is the difference between the Taxes (in $) of Benin in 2011 and the Taxes (in $) of Lithuania in 2012?
Provide a succinct answer. 2.64e+11. What is the difference between the Taxes (in $) of Benin in 2011 and the Taxes (in $) of Philippines in 2012?
Your answer should be compact. -1.53e+11. What is the difference between the Taxes (in $) in Egypt, Arab Rep. in 2011 and the Taxes (in $) in Lithuania in 2012?
Your answer should be compact. 6.40e+1. What is the difference between the Taxes (in $) of Egypt, Arab Rep. in 2011 and the Taxes (in $) of Philippines in 2012?
Give a very brief answer. -3.53e+11. What is the difference between the Taxes (in $) of Lithuania in 2011 and the Taxes (in $) of Philippines in 2012?
Keep it short and to the point. -4.17e+11. What is the average Taxes (in $) of Benin per year?
Keep it short and to the point. 2.49e+11. What is the average Taxes (in $) of Egypt, Arab Rep. per year?
Your answer should be very brief. 5.92e+1. What is the average Taxes (in $) of Lithuania per year?
Provide a succinct answer. 1.10e+1. What is the average Taxes (in $) in Philippines per year?
Keep it short and to the point. 3.36e+11. In the year 2006, what is the difference between the Taxes (in $) in Benin and Taxes (in $) in Egypt, Arab Rep.?
Your answer should be very brief. 1.43e+11. In the year 2006, what is the difference between the Taxes (in $) in Benin and Taxes (in $) in Lithuania?
Make the answer very short. 1.69e+11. In the year 2006, what is the difference between the Taxes (in $) of Benin and Taxes (in $) of Philippines?
Make the answer very short. -1.07e+11. In the year 2006, what is the difference between the Taxes (in $) in Egypt, Arab Rep. and Taxes (in $) in Lithuania?
Keep it short and to the point. 2.58e+1. In the year 2006, what is the difference between the Taxes (in $) in Egypt, Arab Rep. and Taxes (in $) in Philippines?
Your answer should be very brief. -2.50e+11. In the year 2006, what is the difference between the Taxes (in $) in Lithuania and Taxes (in $) in Philippines?
Provide a short and direct response. -2.76e+11. In the year 2007, what is the difference between the Taxes (in $) of Benin and Taxes (in $) of Egypt, Arab Rep.?
Your response must be concise. 1.77e+11. In the year 2007, what is the difference between the Taxes (in $) in Benin and Taxes (in $) in Lithuania?
Offer a very short reply. 2.05e+11. In the year 2007, what is the difference between the Taxes (in $) in Benin and Taxes (in $) in Philippines?
Ensure brevity in your answer.  -8.01e+1. In the year 2007, what is the difference between the Taxes (in $) of Egypt, Arab Rep. and Taxes (in $) of Lithuania?
Keep it short and to the point. 2.84e+1. In the year 2007, what is the difference between the Taxes (in $) in Egypt, Arab Rep. and Taxes (in $) in Philippines?
Give a very brief answer. -2.57e+11. In the year 2007, what is the difference between the Taxes (in $) in Lithuania and Taxes (in $) in Philippines?
Your response must be concise. -2.86e+11. In the year 2008, what is the difference between the Taxes (in $) in Benin and Taxes (in $) in Egypt, Arab Rep.?
Provide a short and direct response. 1.97e+11. In the year 2008, what is the difference between the Taxes (in $) of Benin and Taxes (in $) of Lithuania?
Your answer should be compact. 2.35e+11. In the year 2008, what is the difference between the Taxes (in $) of Benin and Taxes (in $) of Philippines?
Your response must be concise. -5.98e+1. In the year 2008, what is the difference between the Taxes (in $) in Egypt, Arab Rep. and Taxes (in $) in Lithuania?
Give a very brief answer. 3.74e+1. In the year 2008, what is the difference between the Taxes (in $) of Egypt, Arab Rep. and Taxes (in $) of Philippines?
Offer a very short reply. -2.57e+11. In the year 2008, what is the difference between the Taxes (in $) of Lithuania and Taxes (in $) of Philippines?
Your answer should be very brief. -2.94e+11. In the year 2009, what is the difference between the Taxes (in $) of Benin and Taxes (in $) of Egypt, Arab Rep.?
Make the answer very short. 2.00e+11. In the year 2009, what is the difference between the Taxes (in $) of Benin and Taxes (in $) of Lithuania?
Offer a terse response. 2.53e+11. In the year 2009, what is the difference between the Taxes (in $) in Benin and Taxes (in $) in Philippines?
Offer a terse response. -6.30e+1. In the year 2009, what is the difference between the Taxes (in $) of Egypt, Arab Rep. and Taxes (in $) of Lithuania?
Make the answer very short. 5.26e+1. In the year 2009, what is the difference between the Taxes (in $) of Egypt, Arab Rep. and Taxes (in $) of Philippines?
Your response must be concise. -2.63e+11. In the year 2009, what is the difference between the Taxes (in $) in Lithuania and Taxes (in $) in Philippines?
Provide a short and direct response. -3.16e+11. In the year 2010, what is the difference between the Taxes (in $) of Benin and Taxes (in $) of Egypt, Arab Rep.?
Give a very brief answer. 2.01e+11. In the year 2010, what is the difference between the Taxes (in $) of Benin and Taxes (in $) of Lithuania?
Give a very brief answer. 2.58e+11. In the year 2010, what is the difference between the Taxes (in $) of Benin and Taxes (in $) of Philippines?
Your answer should be very brief. -7.68e+1. In the year 2010, what is the difference between the Taxes (in $) in Egypt, Arab Rep. and Taxes (in $) in Lithuania?
Give a very brief answer. 5.63e+1. In the year 2010, what is the difference between the Taxes (in $) in Egypt, Arab Rep. and Taxes (in $) in Philippines?
Ensure brevity in your answer.  -2.78e+11. In the year 2010, what is the difference between the Taxes (in $) in Lithuania and Taxes (in $) in Philippines?
Your answer should be very brief. -3.34e+11. In the year 2011, what is the difference between the Taxes (in $) of Benin and Taxes (in $) of Egypt, Arab Rep.?
Keep it short and to the point. 2.00e+11. In the year 2011, what is the difference between the Taxes (in $) in Benin and Taxes (in $) in Lithuania?
Your response must be concise. 2.64e+11. In the year 2011, what is the difference between the Taxes (in $) in Benin and Taxes (in $) in Philippines?
Ensure brevity in your answer.  -8.93e+1. In the year 2011, what is the difference between the Taxes (in $) in Egypt, Arab Rep. and Taxes (in $) in Lithuania?
Your response must be concise. 6.42e+1. In the year 2011, what is the difference between the Taxes (in $) of Egypt, Arab Rep. and Taxes (in $) of Philippines?
Make the answer very short. -2.89e+11. In the year 2011, what is the difference between the Taxes (in $) of Lithuania and Taxes (in $) of Philippines?
Provide a short and direct response. -3.53e+11. In the year 2012, what is the difference between the Taxes (in $) in Benin and Taxes (in $) in Egypt, Arab Rep.?
Provide a succinct answer. 2.09e+11. In the year 2012, what is the difference between the Taxes (in $) in Benin and Taxes (in $) in Lithuania?
Make the answer very short. 2.82e+11. In the year 2012, what is the difference between the Taxes (in $) of Benin and Taxes (in $) of Philippines?
Make the answer very short. -1.35e+11. In the year 2012, what is the difference between the Taxes (in $) in Egypt, Arab Rep. and Taxes (in $) in Lithuania?
Provide a short and direct response. 7.25e+1. In the year 2012, what is the difference between the Taxes (in $) in Egypt, Arab Rep. and Taxes (in $) in Philippines?
Provide a short and direct response. -3.44e+11. In the year 2012, what is the difference between the Taxes (in $) of Lithuania and Taxes (in $) of Philippines?
Your answer should be compact. -4.17e+11. What is the ratio of the Taxes (in $) in Benin in 2006 to that in 2007?
Your answer should be very brief. 0.82. What is the ratio of the Taxes (in $) of Egypt, Arab Rep. in 2006 to that in 2007?
Keep it short and to the point. 0.88. What is the ratio of the Taxes (in $) of Lithuania in 2006 to that in 2007?
Your answer should be compact. 0.8. What is the ratio of the Taxes (in $) in Philippines in 2006 to that in 2007?
Your answer should be compact. 0.96. What is the ratio of the Taxes (in $) of Benin in 2006 to that in 2008?
Provide a succinct answer. 0.72. What is the ratio of the Taxes (in $) of Egypt, Arab Rep. in 2006 to that in 2008?
Your answer should be compact. 0.7. What is the ratio of the Taxes (in $) of Lithuania in 2006 to that in 2008?
Offer a very short reply. 0.72. What is the ratio of the Taxes (in $) in Philippines in 2006 to that in 2008?
Your answer should be very brief. 0.93. What is the ratio of the Taxes (in $) of Benin in 2006 to that in 2009?
Give a very brief answer. 0.68. What is the ratio of the Taxes (in $) in Egypt, Arab Rep. in 2006 to that in 2009?
Ensure brevity in your answer.  0.55. What is the ratio of the Taxes (in $) in Lithuania in 2006 to that in 2009?
Keep it short and to the point. 0.88. What is the ratio of the Taxes (in $) of Philippines in 2006 to that in 2009?
Offer a very short reply. 0.87. What is the ratio of the Taxes (in $) in Benin in 2006 to that in 2010?
Your answer should be very brief. 0.66. What is the ratio of the Taxes (in $) in Egypt, Arab Rep. in 2006 to that in 2010?
Provide a short and direct response. 0.52. What is the ratio of the Taxes (in $) in Lithuania in 2006 to that in 2010?
Your response must be concise. 0.82. What is the ratio of the Taxes (in $) of Philippines in 2006 to that in 2010?
Offer a terse response. 0.82. What is the ratio of the Taxes (in $) in Benin in 2006 to that in 2011?
Give a very brief answer. 0.64. What is the ratio of the Taxes (in $) in Egypt, Arab Rep. in 2006 to that in 2011?
Your answer should be compact. 0.46. What is the ratio of the Taxes (in $) in Lithuania in 2006 to that in 2011?
Provide a succinct answer. 0.75. What is the ratio of the Taxes (in $) in Philippines in 2006 to that in 2011?
Keep it short and to the point. 0.78. What is the ratio of the Taxes (in $) of Benin in 2006 to that in 2012?
Your response must be concise. 0.6. What is the ratio of the Taxes (in $) in Egypt, Arab Rep. in 2006 to that in 2012?
Offer a terse response. 0.41. What is the ratio of the Taxes (in $) of Lithuania in 2006 to that in 2012?
Offer a very short reply. 0.73. What is the ratio of the Taxes (in $) in Philippines in 2006 to that in 2012?
Keep it short and to the point. 0.66. What is the ratio of the Taxes (in $) of Benin in 2007 to that in 2008?
Give a very brief answer. 0.88. What is the ratio of the Taxes (in $) in Egypt, Arab Rep. in 2007 to that in 2008?
Make the answer very short. 0.79. What is the ratio of the Taxes (in $) of Lithuania in 2007 to that in 2008?
Keep it short and to the point. 0.89. What is the ratio of the Taxes (in $) of Philippines in 2007 to that in 2008?
Your answer should be compact. 0.97. What is the ratio of the Taxes (in $) in Benin in 2007 to that in 2009?
Provide a short and direct response. 0.82. What is the ratio of the Taxes (in $) in Egypt, Arab Rep. in 2007 to that in 2009?
Provide a short and direct response. 0.63. What is the ratio of the Taxes (in $) of Lithuania in 2007 to that in 2009?
Your response must be concise. 1.1. What is the ratio of the Taxes (in $) of Philippines in 2007 to that in 2009?
Offer a very short reply. 0.91. What is the ratio of the Taxes (in $) in Benin in 2007 to that in 2010?
Provide a short and direct response. 0.81. What is the ratio of the Taxes (in $) of Egypt, Arab Rep. in 2007 to that in 2010?
Make the answer very short. 0.59. What is the ratio of the Taxes (in $) in Lithuania in 2007 to that in 2010?
Keep it short and to the point. 1.03. What is the ratio of the Taxes (in $) in Philippines in 2007 to that in 2010?
Your answer should be compact. 0.86. What is the ratio of the Taxes (in $) of Benin in 2007 to that in 2011?
Keep it short and to the point. 0.79. What is the ratio of the Taxes (in $) in Egypt, Arab Rep. in 2007 to that in 2011?
Keep it short and to the point. 0.52. What is the ratio of the Taxes (in $) in Lithuania in 2007 to that in 2011?
Make the answer very short. 0.93. What is the ratio of the Taxes (in $) in Philippines in 2007 to that in 2011?
Provide a succinct answer. 0.81. What is the ratio of the Taxes (in $) of Benin in 2007 to that in 2012?
Keep it short and to the point. 0.74. What is the ratio of the Taxes (in $) in Egypt, Arab Rep. in 2007 to that in 2012?
Your answer should be very brief. 0.47. What is the ratio of the Taxes (in $) of Lithuania in 2007 to that in 2012?
Your response must be concise. 0.91. What is the ratio of the Taxes (in $) of Philippines in 2007 to that in 2012?
Ensure brevity in your answer.  0.69. What is the ratio of the Taxes (in $) in Benin in 2008 to that in 2009?
Your response must be concise. 0.94. What is the ratio of the Taxes (in $) in Egypt, Arab Rep. in 2008 to that in 2009?
Provide a short and direct response. 0.79. What is the ratio of the Taxes (in $) of Lithuania in 2008 to that in 2009?
Give a very brief answer. 1.23. What is the ratio of the Taxes (in $) of Philippines in 2008 to that in 2009?
Your response must be concise. 0.94. What is the ratio of the Taxes (in $) of Benin in 2008 to that in 2010?
Your answer should be compact. 0.92. What is the ratio of the Taxes (in $) in Egypt, Arab Rep. in 2008 to that in 2010?
Provide a short and direct response. 0.74. What is the ratio of the Taxes (in $) of Lithuania in 2008 to that in 2010?
Offer a terse response. 1.15. What is the ratio of the Taxes (in $) in Philippines in 2008 to that in 2010?
Your answer should be compact. 0.89. What is the ratio of the Taxes (in $) of Benin in 2008 to that in 2011?
Provide a succinct answer. 0.9. What is the ratio of the Taxes (in $) in Egypt, Arab Rep. in 2008 to that in 2011?
Provide a succinct answer. 0.65. What is the ratio of the Taxes (in $) of Lithuania in 2008 to that in 2011?
Your answer should be compact. 1.04. What is the ratio of the Taxes (in $) in Philippines in 2008 to that in 2011?
Give a very brief answer. 0.84. What is the ratio of the Taxes (in $) in Benin in 2008 to that in 2012?
Your response must be concise. 0.84. What is the ratio of the Taxes (in $) in Egypt, Arab Rep. in 2008 to that in 2012?
Your answer should be compact. 0.59. What is the ratio of the Taxes (in $) in Lithuania in 2008 to that in 2012?
Your response must be concise. 1.02. What is the ratio of the Taxes (in $) in Philippines in 2008 to that in 2012?
Your response must be concise. 0.72. What is the ratio of the Taxes (in $) of Benin in 2009 to that in 2010?
Your answer should be very brief. 0.98. What is the ratio of the Taxes (in $) in Egypt, Arab Rep. in 2009 to that in 2010?
Give a very brief answer. 0.93. What is the ratio of the Taxes (in $) in Lithuania in 2009 to that in 2010?
Offer a terse response. 0.93. What is the ratio of the Taxes (in $) in Philippines in 2009 to that in 2010?
Make the answer very short. 0.94. What is the ratio of the Taxes (in $) of Benin in 2009 to that in 2011?
Provide a succinct answer. 0.95. What is the ratio of the Taxes (in $) in Egypt, Arab Rep. in 2009 to that in 2011?
Make the answer very short. 0.82. What is the ratio of the Taxes (in $) in Lithuania in 2009 to that in 2011?
Offer a terse response. 0.85. What is the ratio of the Taxes (in $) of Philippines in 2009 to that in 2011?
Keep it short and to the point. 0.89. What is the ratio of the Taxes (in $) of Benin in 2009 to that in 2012?
Your answer should be compact. 0.89. What is the ratio of the Taxes (in $) in Egypt, Arab Rep. in 2009 to that in 2012?
Offer a terse response. 0.74. What is the ratio of the Taxes (in $) in Lithuania in 2009 to that in 2012?
Provide a succinct answer. 0.83. What is the ratio of the Taxes (in $) in Philippines in 2009 to that in 2012?
Your answer should be very brief. 0.76. What is the ratio of the Taxes (in $) of Benin in 2010 to that in 2011?
Provide a succinct answer. 0.97. What is the ratio of the Taxes (in $) of Egypt, Arab Rep. in 2010 to that in 2011?
Keep it short and to the point. 0.88. What is the ratio of the Taxes (in $) in Lithuania in 2010 to that in 2011?
Ensure brevity in your answer.  0.91. What is the ratio of the Taxes (in $) in Philippines in 2010 to that in 2011?
Provide a succinct answer. 0.95. What is the ratio of the Taxes (in $) in Benin in 2010 to that in 2012?
Provide a succinct answer. 0.91. What is the ratio of the Taxes (in $) in Egypt, Arab Rep. in 2010 to that in 2012?
Provide a short and direct response. 0.79. What is the ratio of the Taxes (in $) of Lithuania in 2010 to that in 2012?
Make the answer very short. 0.89. What is the ratio of the Taxes (in $) in Philippines in 2010 to that in 2012?
Provide a succinct answer. 0.81. What is the ratio of the Taxes (in $) in Benin in 2011 to that in 2012?
Provide a succinct answer. 0.94. What is the ratio of the Taxes (in $) of Egypt, Arab Rep. in 2011 to that in 2012?
Your response must be concise. 0.9. What is the ratio of the Taxes (in $) in Lithuania in 2011 to that in 2012?
Your answer should be very brief. 0.98. What is the ratio of the Taxes (in $) of Philippines in 2011 to that in 2012?
Give a very brief answer. 0.85. What is the difference between the highest and the second highest Taxes (in $) of Benin?
Offer a terse response. 1.81e+1. What is the difference between the highest and the second highest Taxes (in $) in Egypt, Arab Rep.?
Offer a very short reply. 8.53e+09. What is the difference between the highest and the second highest Taxes (in $) of Lithuania?
Offer a terse response. 2.98e+08. What is the difference between the highest and the second highest Taxes (in $) of Philippines?
Keep it short and to the point. 6.37e+1. What is the difference between the highest and the lowest Taxes (in $) of Benin?
Your answer should be compact. 1.16e+11. What is the difference between the highest and the lowest Taxes (in $) of Egypt, Arab Rep.?
Give a very brief answer. 4.99e+1. What is the difference between the highest and the lowest Taxes (in $) of Lithuania?
Your response must be concise. 3.50e+09. What is the difference between the highest and the lowest Taxes (in $) in Philippines?
Your answer should be very brief. 1.44e+11. 